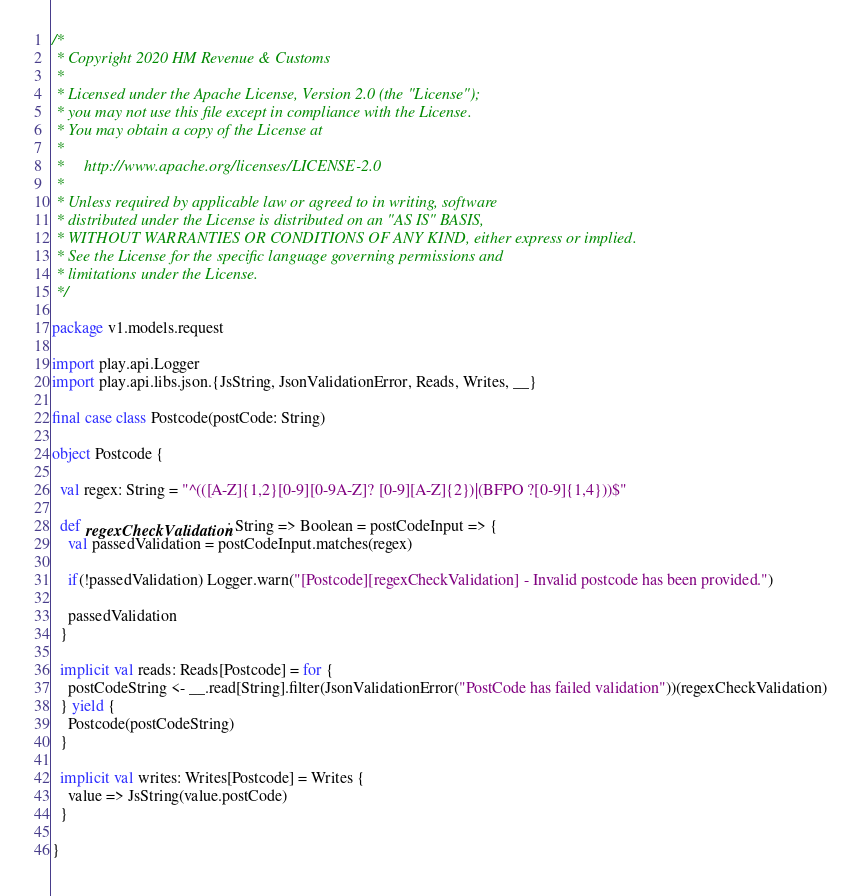<code> <loc_0><loc_0><loc_500><loc_500><_Scala_>/*
 * Copyright 2020 HM Revenue & Customs
 *
 * Licensed under the Apache License, Version 2.0 (the "License");
 * you may not use this file except in compliance with the License.
 * You may obtain a copy of the License at
 *
 *     http://www.apache.org/licenses/LICENSE-2.0
 *
 * Unless required by applicable law or agreed to in writing, software
 * distributed under the License is distributed on an "AS IS" BASIS,
 * WITHOUT WARRANTIES OR CONDITIONS OF ANY KIND, either express or implied.
 * See the License for the specific language governing permissions and
 * limitations under the License.
 */

package v1.models.request

import play.api.Logger
import play.api.libs.json.{JsString, JsonValidationError, Reads, Writes, __}

final case class Postcode(postCode: String)

object Postcode {

  val regex: String = "^(([A-Z]{1,2}[0-9][0-9A-Z]? [0-9][A-Z]{2})|(BFPO ?[0-9]{1,4}))$"

  def regexCheckValidation: String => Boolean = postCodeInput => {
    val passedValidation = postCodeInput.matches(regex)

    if(!passedValidation) Logger.warn("[Postcode][regexCheckValidation] - Invalid postcode has been provided.")

    passedValidation
  }

  implicit val reads: Reads[Postcode] = for {
    postCodeString <- __.read[String].filter(JsonValidationError("PostCode has failed validation"))(regexCheckValidation)
  } yield {
    Postcode(postCodeString)
  }

  implicit val writes: Writes[Postcode] = Writes {
    value => JsString(value.postCode)
  }

}
</code> 